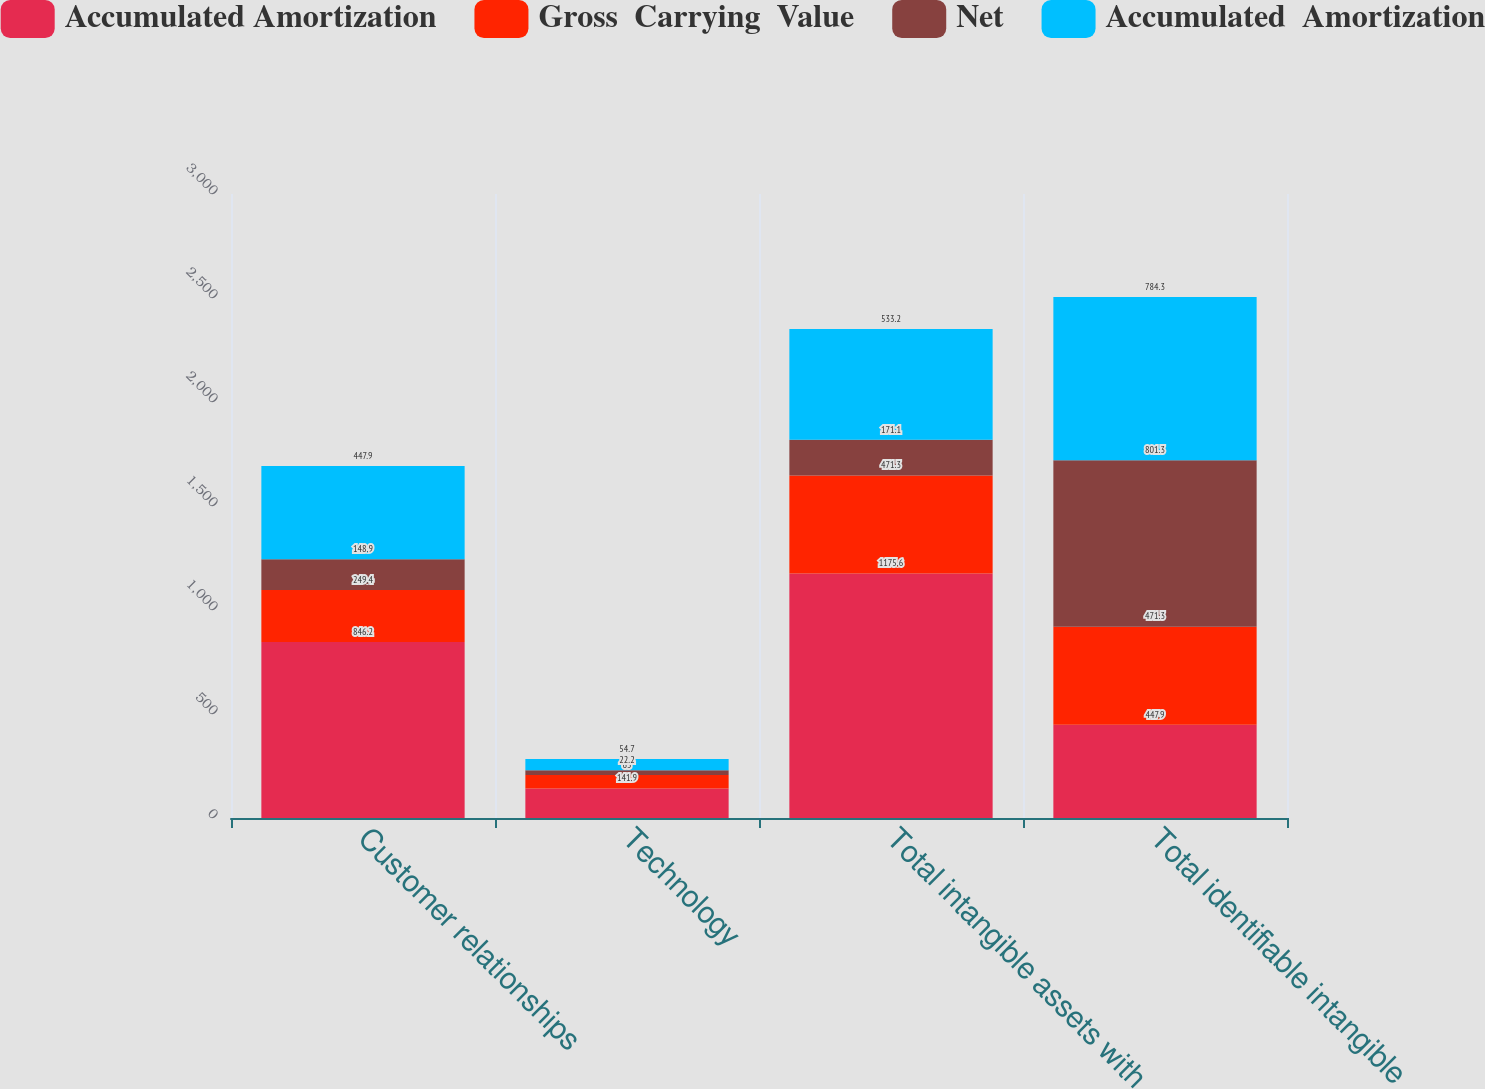Convert chart. <chart><loc_0><loc_0><loc_500><loc_500><stacked_bar_chart><ecel><fcel>Customer relationships<fcel>Technology<fcel>Total intangible assets with<fcel>Total identifiable intangible<nl><fcel>Accumulated Amortization<fcel>846.2<fcel>141.9<fcel>1175.6<fcel>447.9<nl><fcel>Gross  Carrying  Value<fcel>249.4<fcel>65<fcel>471.3<fcel>471.3<nl><fcel>Net<fcel>148.9<fcel>22.2<fcel>171.1<fcel>801.3<nl><fcel>Accumulated  Amortization<fcel>447.9<fcel>54.7<fcel>533.2<fcel>784.3<nl></chart> 